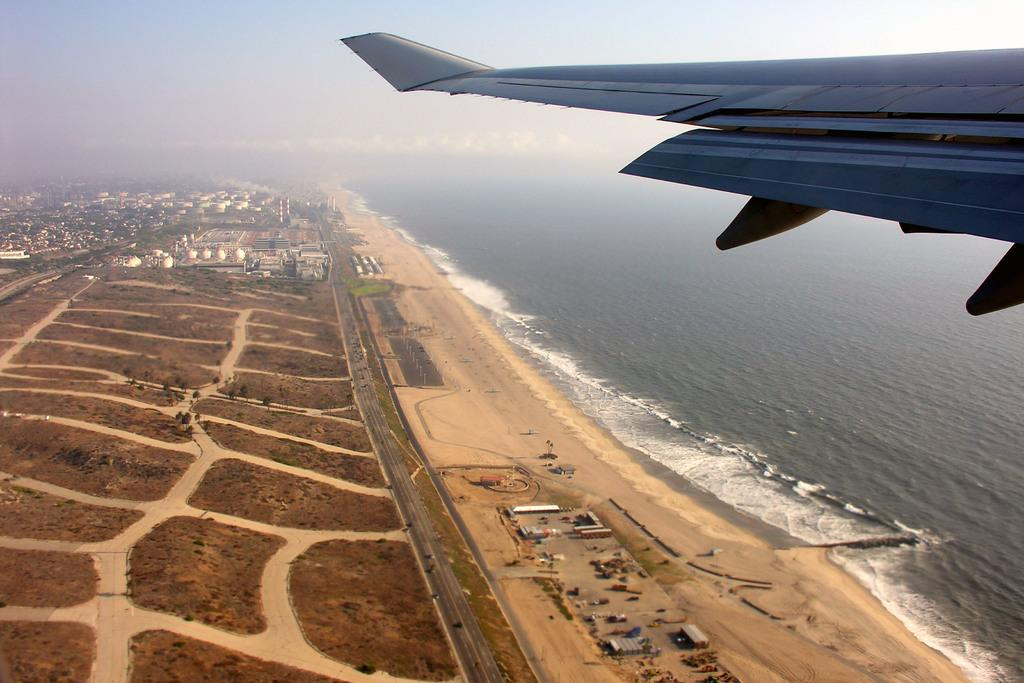What is the main subject of the image? The main subject of the image is an airplane wing in the air. What type of natural environment can be seen in the image? There are trees visible in the image. What type of man-made structure can be seen in the image? There is a road in the image. What type of water feature can be seen in the image? There is water visible in the image. What type of structures can be seen in the background of the image? There are buildings in the background of the image. What part of the natural environment is visible in the background of the image? The sky is visible in the background of the image. How many legs can be seen on the band members in the image? There are no band members or legs present in the image. 